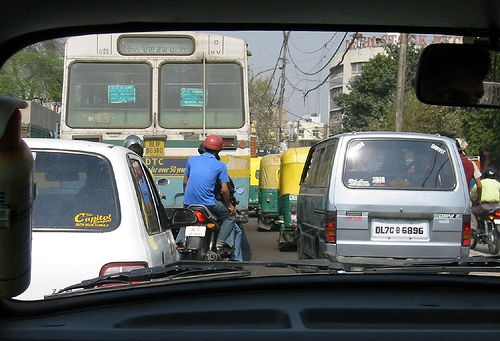Describe the objects in this image and their specific colors. I can see bus in black, gray, darkgray, lightgray, and teal tones, car in black, gray, lightgray, and darkgray tones, car in black, white, gray, and darkgray tones, people in black, lightblue, gray, and blue tones, and motorcycle in black, gray, white, and darkgray tones in this image. 